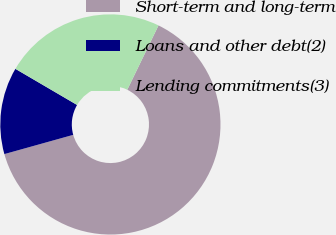<chart> <loc_0><loc_0><loc_500><loc_500><pie_chart><fcel>Short-term and long-term<fcel>Loans and other debt(2)<fcel>Lending commitments(3)<nl><fcel>63.47%<fcel>12.77%<fcel>23.77%<nl></chart> 